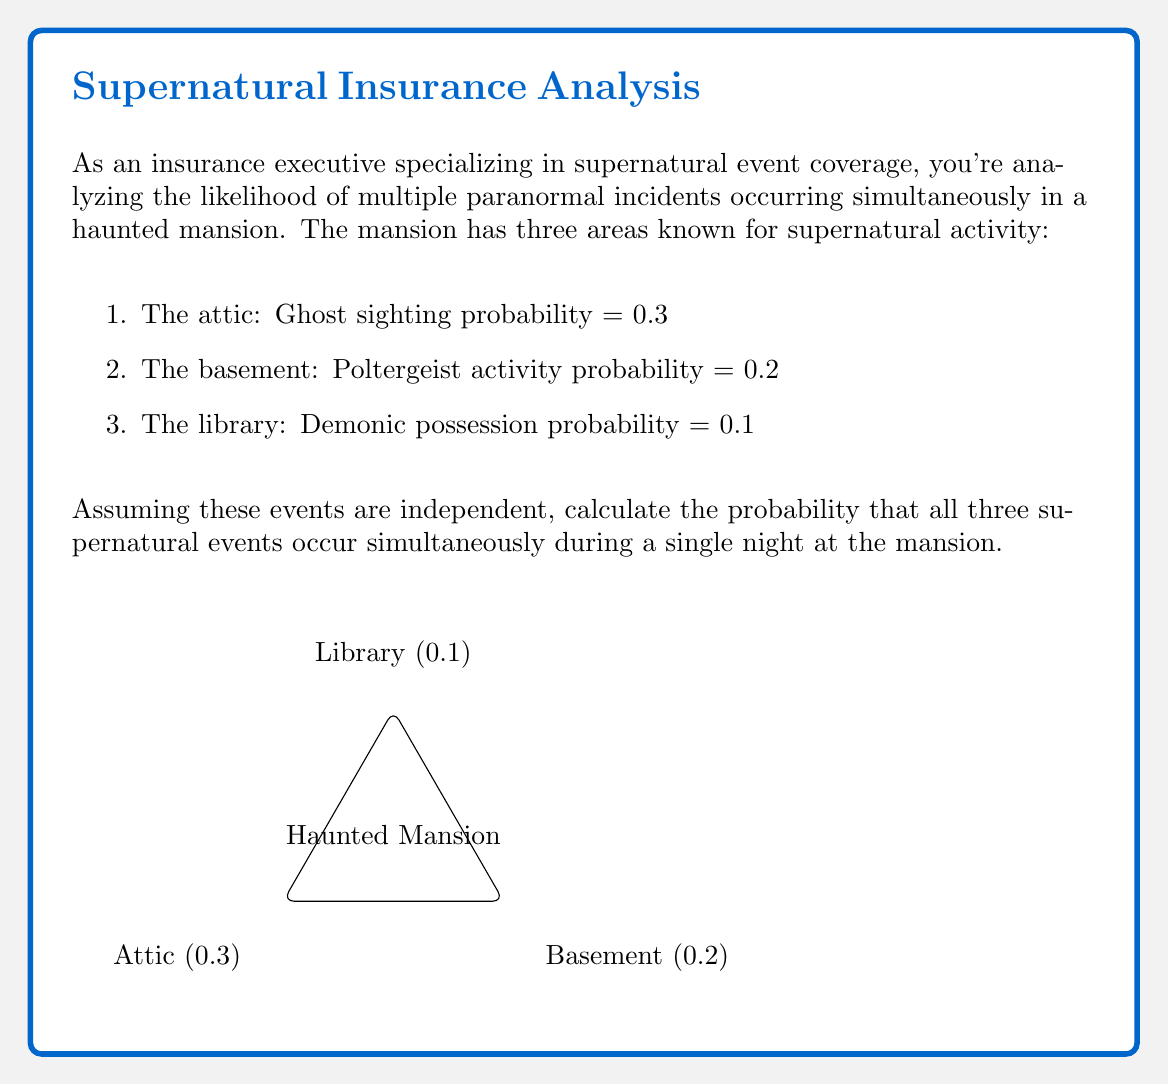Help me with this question. To solve this problem, we'll use the multiplication rule for independent events. Since the events are assumed to be independent, we multiply the individual probabilities of each event occurring.

Let's define our events:
A = Ghost sighting in the attic
B = Poltergeist activity in the basement
C = Demonic possession in the library

We want to find P(A ∩ B ∩ C), the probability of all three events occurring simultaneously.

Given:
P(A) = 0.3
P(B) = 0.2
P(C) = 0.1

For independent events:
$$P(A \cap B \cap C) = P(A) \times P(B) \times P(C)$$

Substituting the values:

$$P(A \cap B \cap C) = 0.3 \times 0.2 \times 0.1$$

Calculating:
$$P(A \cap B \cap C) = 0.006$$

Therefore, the probability of all three supernatural events occurring simultaneously is 0.006 or 0.6%.
Answer: 0.006 